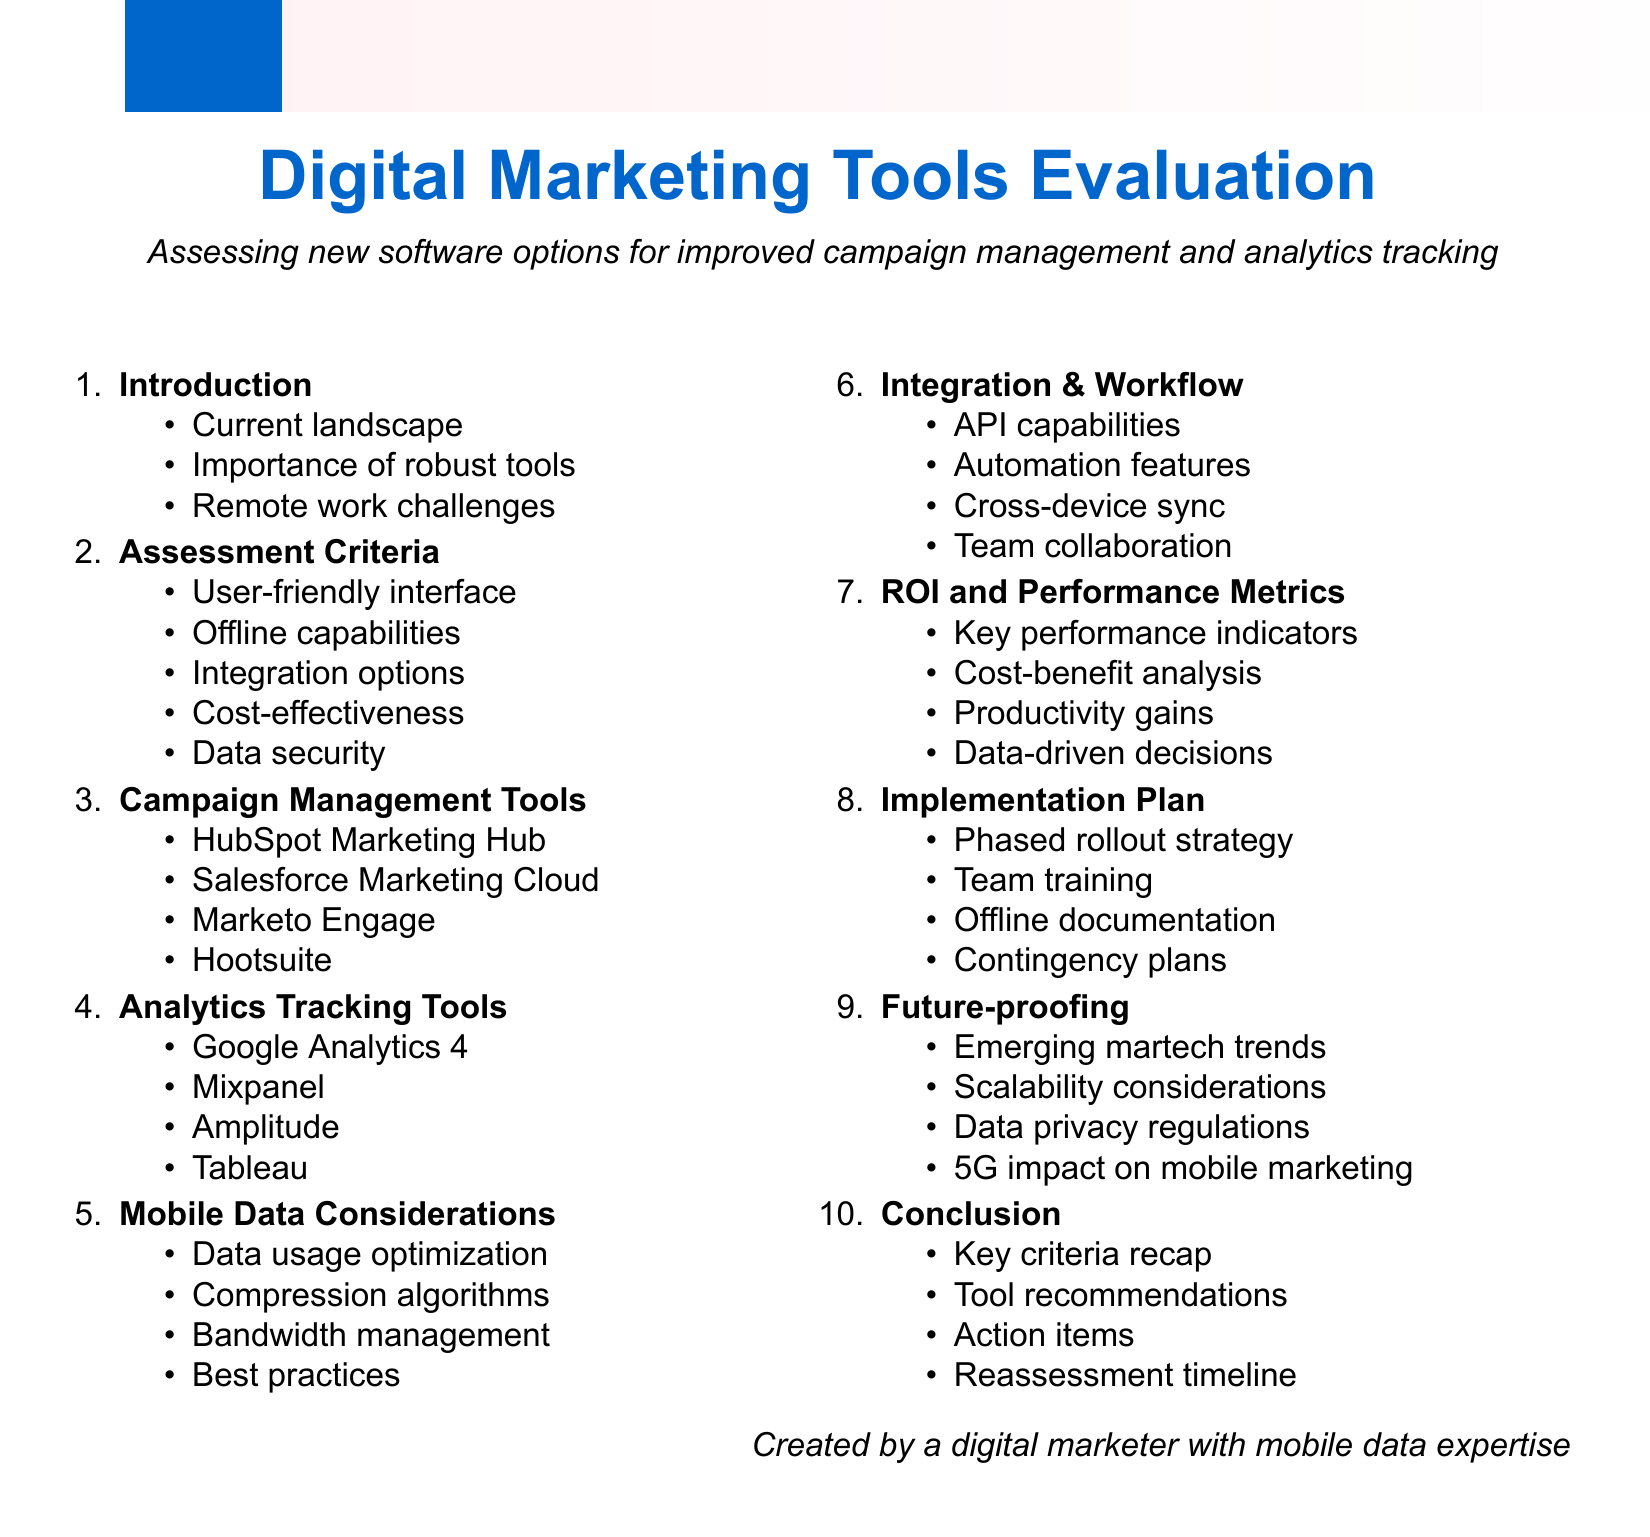What is the first item in the agenda? The first item in the agenda is titled "Introduction to Digital Marketing Tools Evaluation."
Answer: Introduction to Digital Marketing Tools Evaluation Which tool has offline capabilities among the campaign management tools? The campaign management tool that has offline capabilities is Salesforce Marketing Cloud.
Answer: Salesforce Marketing Cloud What is a key performance indicator mentioned in the ROI and performance metrics? A key performance indicator for evaluating tool effectiveness is mentioned in the ROI and performance metrics section.
Answer: Key performance indicators What is the purpose of data usage optimization techniques? Data usage optimization techniques are focused on optimizing the use of mobile data for marketing tools.
Answer: Optimizing mobile data usage What is the last agenda item? The last agenda item in the document is "Conclusion and Next Steps."
Answer: Conclusion and Next Steps How many assessment criteria are listed for new software? There are five assessment criteria listed for new software options.
Answer: Five Which analytics tracking tool offers real-time user analytics? The analytics tracking tool that offers real-time user analytics is Mixpanel.
Answer: Mixpanel What is one consideration for future-proofing the digital marketing stack? An emerging trend in martech, such as AI or machine learning, is a consideration for future-proofing.
Answer: AI or machine learning 